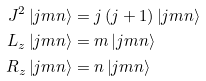<formula> <loc_0><loc_0><loc_500><loc_500>J ^ { 2 } \left | j m n \right \rangle & = j \left ( j + 1 \right ) \left | j m n \right \rangle \\ L _ { z } \left | j m n \right \rangle & = m \left | j m n \right \rangle \\ R _ { z } \left | j m n \right \rangle & = n \left | j m n \right \rangle</formula> 